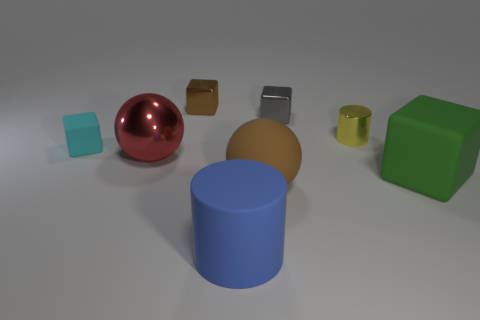What is the size of the metal block in front of the shiny block that is behind the tiny gray object that is on the left side of the tiny yellow metallic cylinder?
Provide a succinct answer. Small. What material is the cylinder in front of the tiny rubber object?
Make the answer very short. Rubber. What number of other things are the same shape as the tiny rubber thing?
Provide a succinct answer. 3. Is the shape of the small brown shiny thing the same as the yellow shiny object?
Offer a terse response. No. Are there any yellow shiny things right of the shiny sphere?
Your answer should be compact. Yes. How many things are either big red rubber blocks or tiny gray blocks?
Your answer should be very brief. 1. How many other things are the same size as the yellow thing?
Provide a succinct answer. 3. What number of things are both in front of the small matte block and behind the matte ball?
Give a very brief answer. 2. There is a rubber object behind the green rubber cube; is its size the same as the shiny block in front of the tiny brown shiny object?
Offer a very short reply. Yes. There is a cylinder that is on the left side of the brown rubber ball; what size is it?
Ensure brevity in your answer.  Large. 